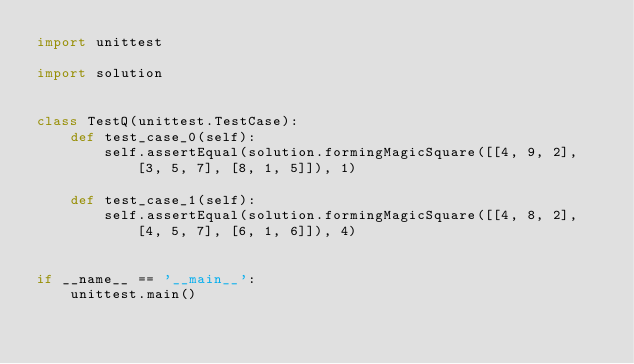Convert code to text. <code><loc_0><loc_0><loc_500><loc_500><_Python_>import unittest

import solution


class TestQ(unittest.TestCase):
    def test_case_0(self):
        self.assertEqual(solution.formingMagicSquare([[4, 9, 2], [3, 5, 7], [8, 1, 5]]), 1)

    def test_case_1(self):
        self.assertEqual(solution.formingMagicSquare([[4, 8, 2], [4, 5, 7], [6, 1, 6]]), 4)


if __name__ == '__main__':
    unittest.main()
</code> 